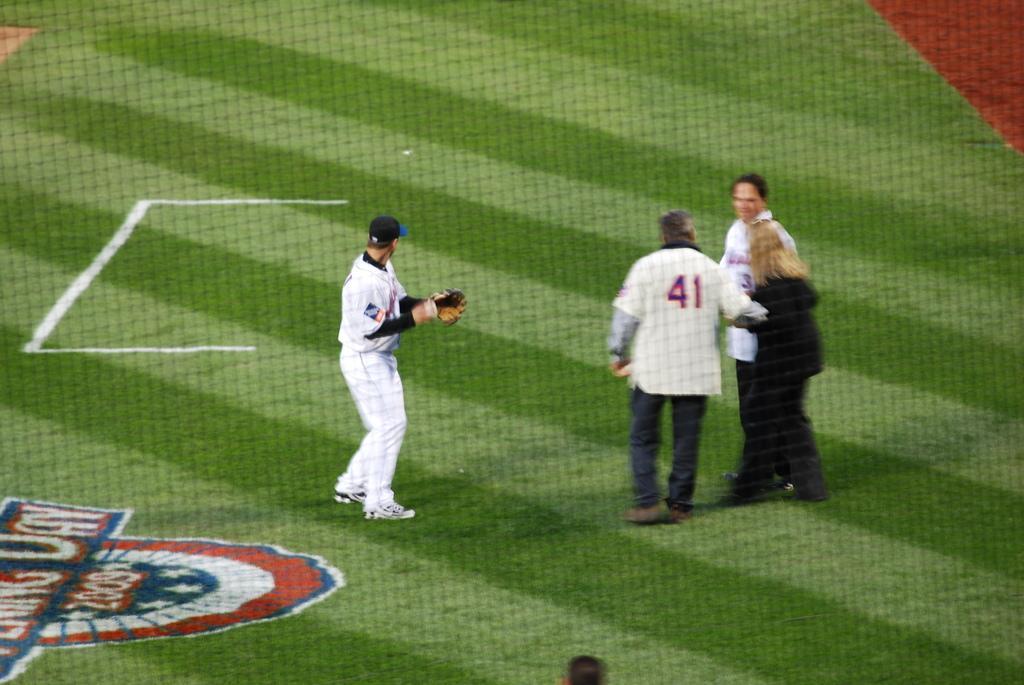In one or two sentences, can you explain what this image depicts? There are people standing and a player on the grassland in the foreground area of the image, it seems like a ground. 